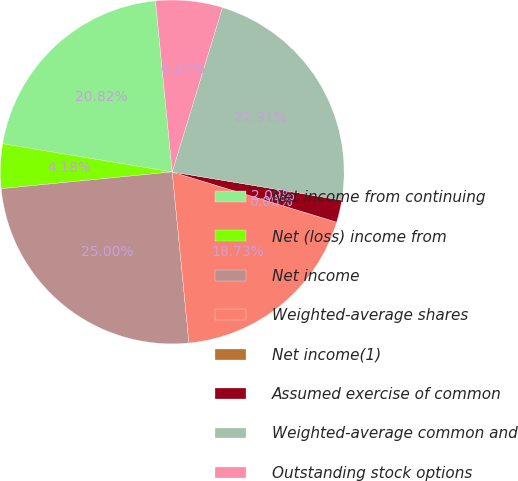Convert chart. <chart><loc_0><loc_0><loc_500><loc_500><pie_chart><fcel>Net income from continuing<fcel>Net (loss) income from<fcel>Net income<fcel>Weighted-average shares<fcel>Net income(1)<fcel>Assumed exercise of common<fcel>Weighted-average common and<fcel>Outstanding stock options<nl><fcel>20.82%<fcel>4.18%<fcel>25.0%<fcel>18.73%<fcel>0.0%<fcel>2.09%<fcel>22.91%<fcel>6.27%<nl></chart> 